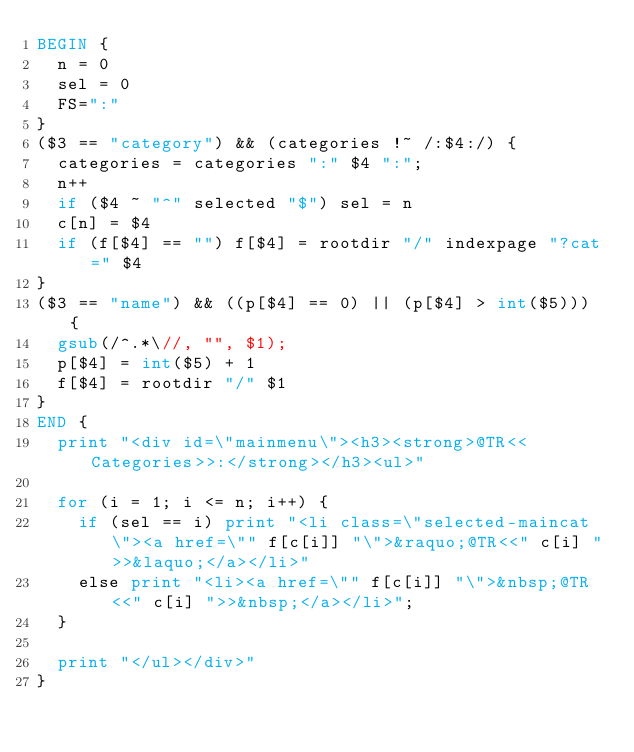<code> <loc_0><loc_0><loc_500><loc_500><_Awk_>BEGIN {
	n = 0
	sel = 0
	FS=":"
}
($3 == "category") && (categories !~ /:$4:/) {
	categories = categories ":" $4 ":";
 	n++
	if ($4 ~ "^" selected "$") sel = n
	c[n] = $4
	if (f[$4] == "") f[$4] = rootdir "/" indexpage "?cat=" $4
}
($3 == "name") && ((p[$4] == 0) || (p[$4] > int($5))) {
	gsub(/^.*\//, "", $1);
	p[$4] = int($5) + 1
	f[$4] = rootdir "/" $1
}
END {
	print "<div id=\"mainmenu\"><h3><strong>@TR<<Categories>>:</strong></h3><ul>"
	
	for (i = 1; i <= n; i++) {
		if (sel == i) print "<li class=\"selected-maincat\"><a href=\"" f[c[i]] "\">&raquo;@TR<<" c[i] ">>&laquo;</a></li>"
		else print "<li><a href=\"" f[c[i]] "\">&nbsp;@TR<<" c[i] ">>&nbsp;</a></li>";
	}
  
	print "</ul></div>"
}
</code> 